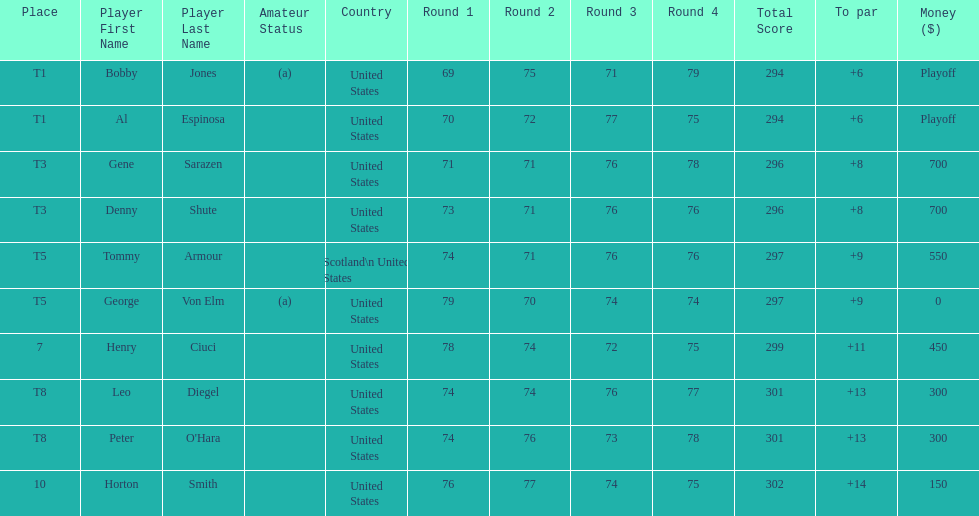Gene sarazen and denny shute are both from which country? United States. 